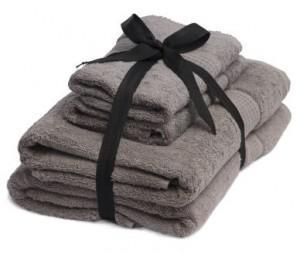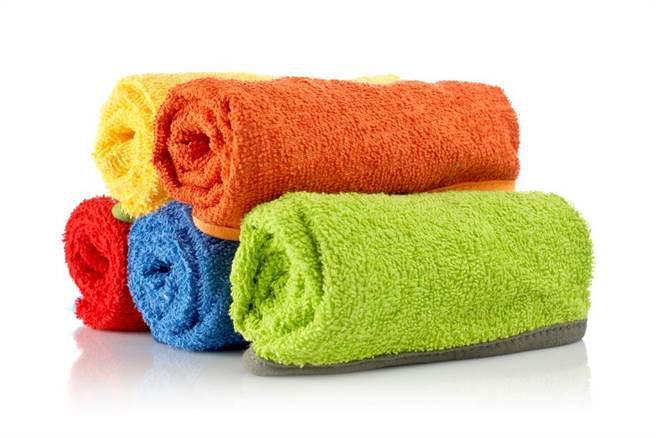The first image is the image on the left, the second image is the image on the right. Considering the images on both sides, is "In the right image, there is a white towel with a white and yellow striped strip of ribbon" valid? Answer yes or no. No. The first image is the image on the left, the second image is the image on the right. Analyze the images presented: Is the assertion "There is a white towel with a yellow and white band down the center in the image on the right." valid? Answer yes or no. No. 